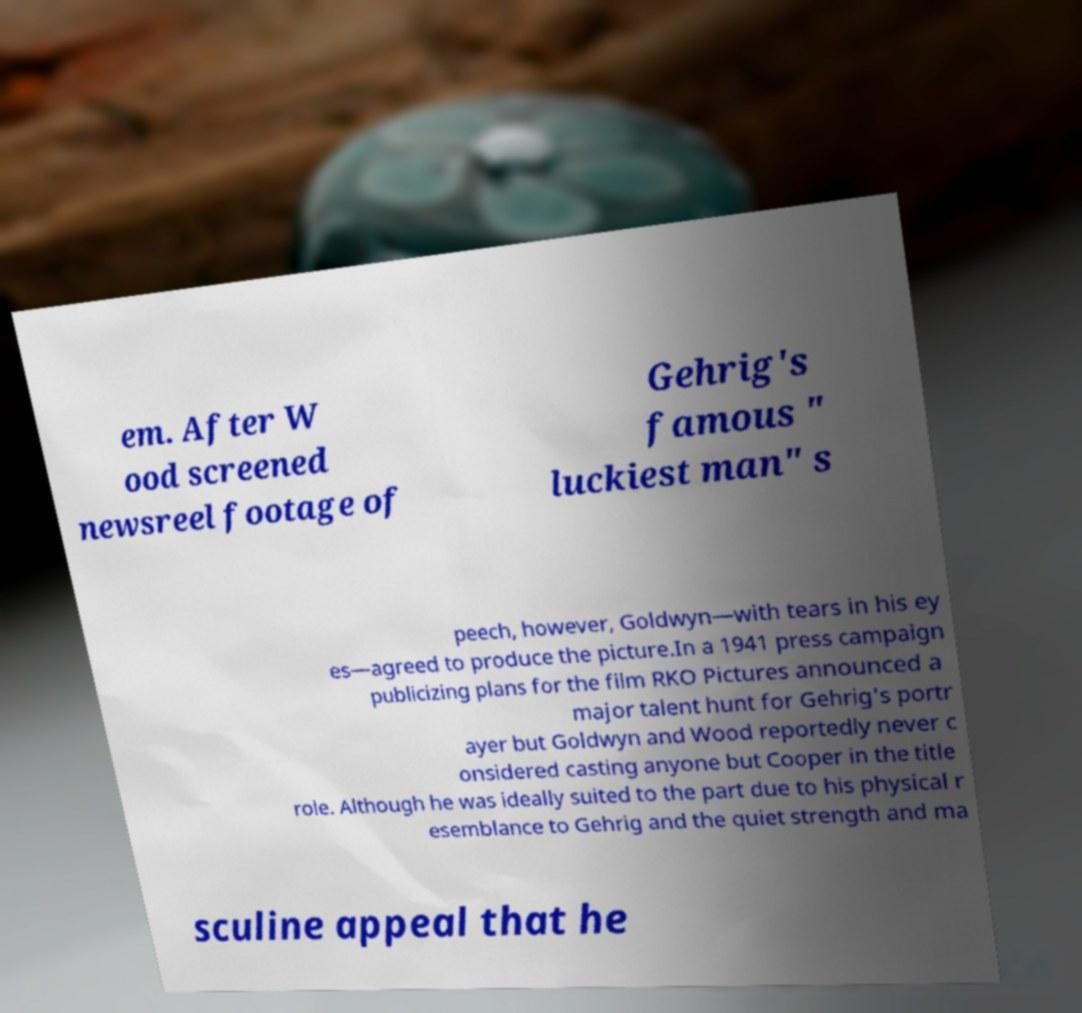Please read and relay the text visible in this image. What does it say? em. After W ood screened newsreel footage of Gehrig's famous " luckiest man" s peech, however, Goldwyn—with tears in his ey es—agreed to produce the picture.In a 1941 press campaign publicizing plans for the film RKO Pictures announced a major talent hunt for Gehrig's portr ayer but Goldwyn and Wood reportedly never c onsidered casting anyone but Cooper in the title role. Although he was ideally suited to the part due to his physical r esemblance to Gehrig and the quiet strength and ma sculine appeal that he 